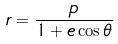<formula> <loc_0><loc_0><loc_500><loc_500>r = \frac { p } { 1 + e \cos \theta }</formula> 